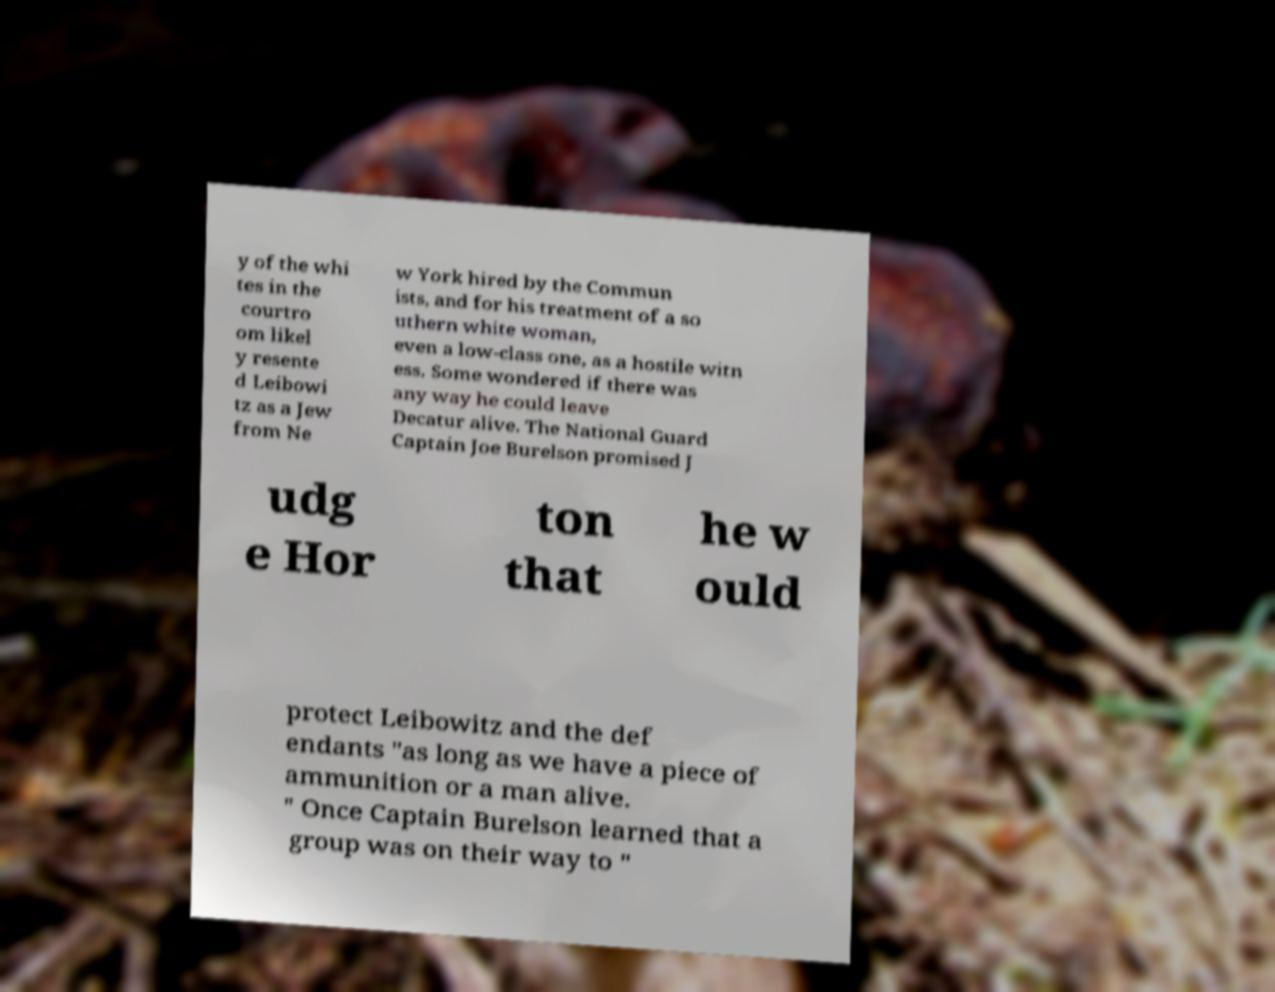What messages or text are displayed in this image? I need them in a readable, typed format. y of the whi tes in the courtro om likel y resente d Leibowi tz as a Jew from Ne w York hired by the Commun ists, and for his treatment of a so uthern white woman, even a low-class one, as a hostile witn ess. Some wondered if there was any way he could leave Decatur alive. The National Guard Captain Joe Burelson promised J udg e Hor ton that he w ould protect Leibowitz and the def endants "as long as we have a piece of ammunition or a man alive. " Once Captain Burelson learned that a group was on their way to " 